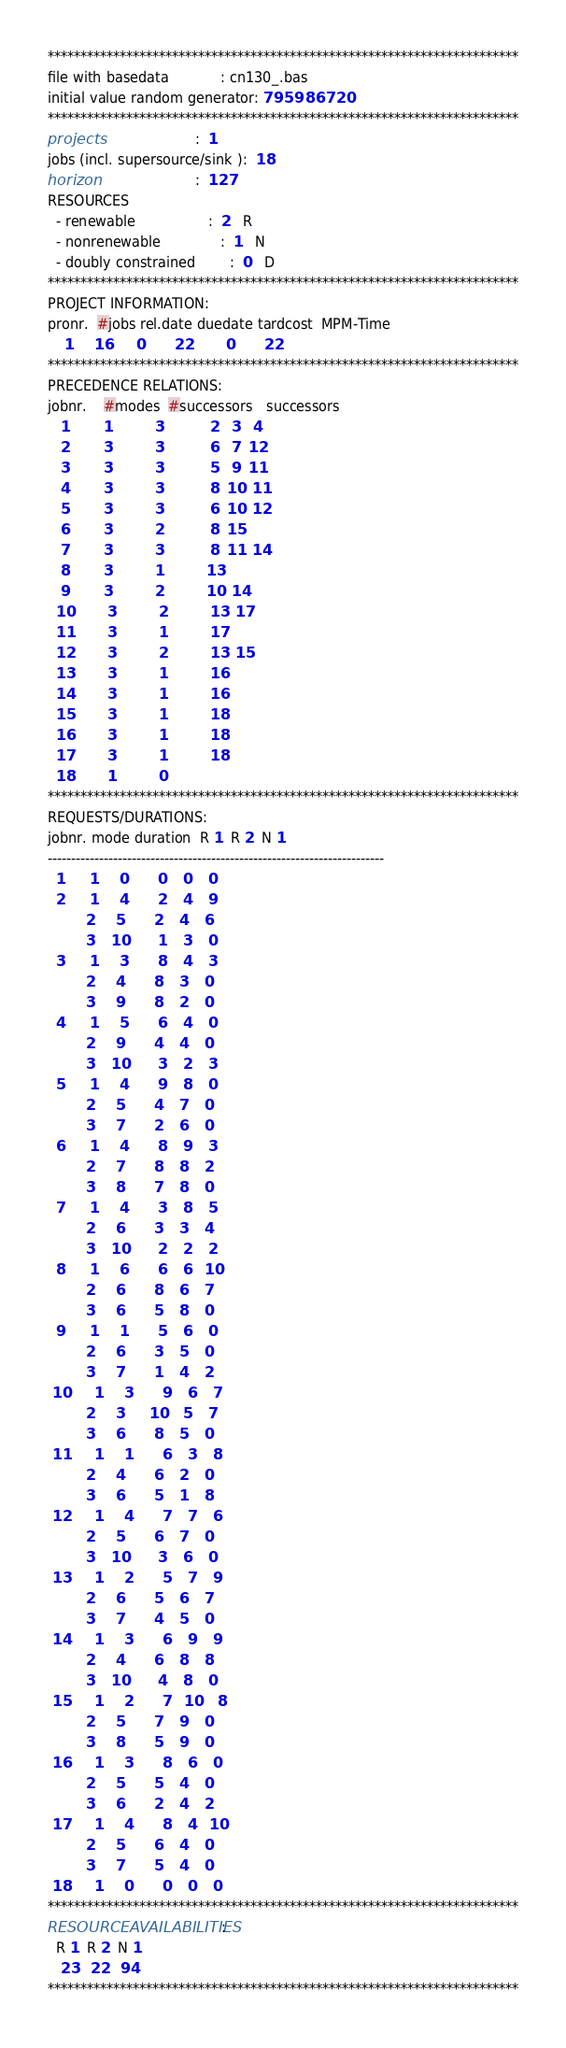<code> <loc_0><loc_0><loc_500><loc_500><_ObjectiveC_>************************************************************************
file with basedata            : cn130_.bas
initial value random generator: 795986720
************************************************************************
projects                      :  1
jobs (incl. supersource/sink ):  18
horizon                       :  127
RESOURCES
  - renewable                 :  2   R
  - nonrenewable              :  1   N
  - doubly constrained        :  0   D
************************************************************************
PROJECT INFORMATION:
pronr.  #jobs rel.date duedate tardcost  MPM-Time
    1     16      0       22        0       22
************************************************************************
PRECEDENCE RELATIONS:
jobnr.    #modes  #successors   successors
   1        1          3           2   3   4
   2        3          3           6   7  12
   3        3          3           5   9  11
   4        3          3           8  10  11
   5        3          3           6  10  12
   6        3          2           8  15
   7        3          3           8  11  14
   8        3          1          13
   9        3          2          10  14
  10        3          2          13  17
  11        3          1          17
  12        3          2          13  15
  13        3          1          16
  14        3          1          16
  15        3          1          18
  16        3          1          18
  17        3          1          18
  18        1          0        
************************************************************************
REQUESTS/DURATIONS:
jobnr. mode duration  R 1  R 2  N 1
------------------------------------------------------------------------
  1      1     0       0    0    0
  2      1     4       2    4    9
         2     5       2    4    6
         3    10       1    3    0
  3      1     3       8    4    3
         2     4       8    3    0
         3     9       8    2    0
  4      1     5       6    4    0
         2     9       4    4    0
         3    10       3    2    3
  5      1     4       9    8    0
         2     5       4    7    0
         3     7       2    6    0
  6      1     4       8    9    3
         2     7       8    8    2
         3     8       7    8    0
  7      1     4       3    8    5
         2     6       3    3    4
         3    10       2    2    2
  8      1     6       6    6   10
         2     6       8    6    7
         3     6       5    8    0
  9      1     1       5    6    0
         2     6       3    5    0
         3     7       1    4    2
 10      1     3       9    6    7
         2     3      10    5    7
         3     6       8    5    0
 11      1     1       6    3    8
         2     4       6    2    0
         3     6       5    1    8
 12      1     4       7    7    6
         2     5       6    7    0
         3    10       3    6    0
 13      1     2       5    7    9
         2     6       5    6    7
         3     7       4    5    0
 14      1     3       6    9    9
         2     4       6    8    8
         3    10       4    8    0
 15      1     2       7   10    8
         2     5       7    9    0
         3     8       5    9    0
 16      1     3       8    6    0
         2     5       5    4    0
         3     6       2    4    2
 17      1     4       8    4   10
         2     5       6    4    0
         3     7       5    4    0
 18      1     0       0    0    0
************************************************************************
RESOURCEAVAILABILITIES:
  R 1  R 2  N 1
   23   22   94
************************************************************************
</code> 